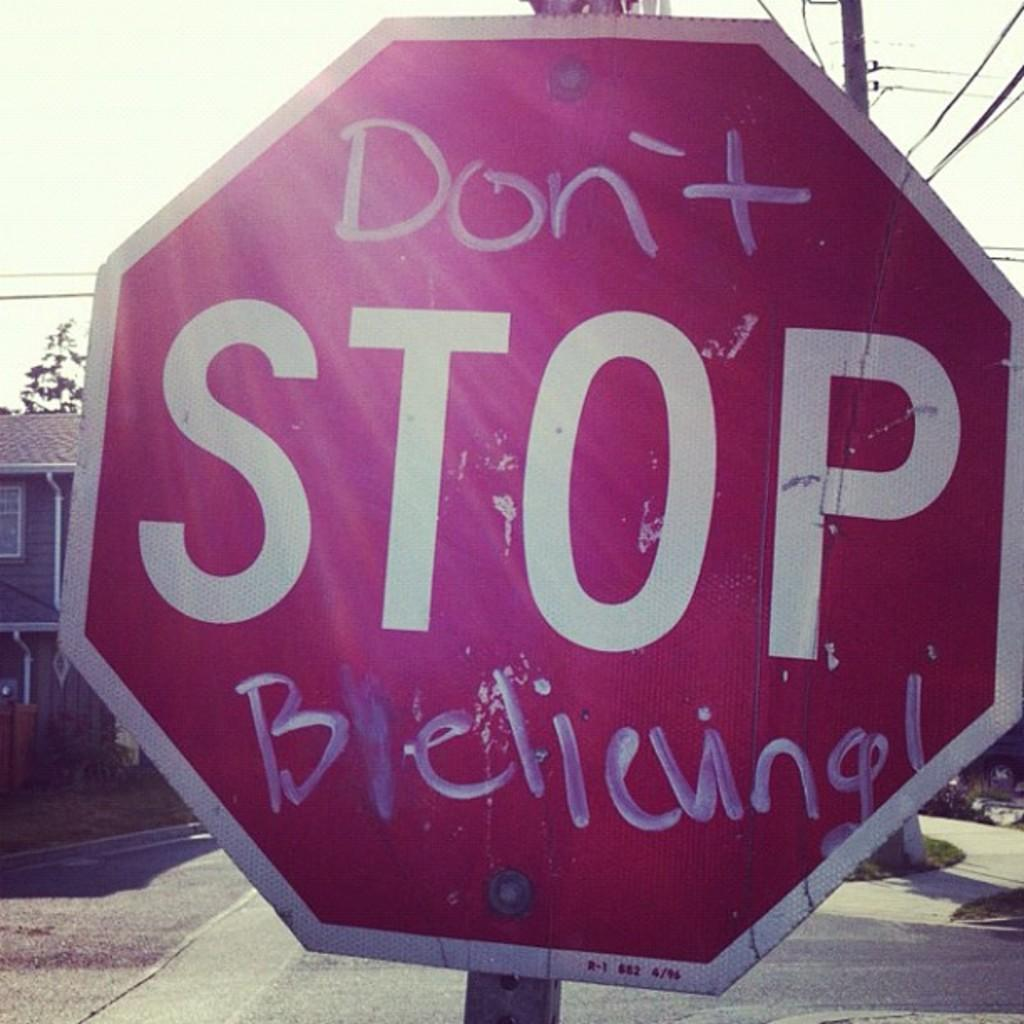<image>
Describe the image concisely. A stop sign has been written on to be the title of a famous Journey song. 